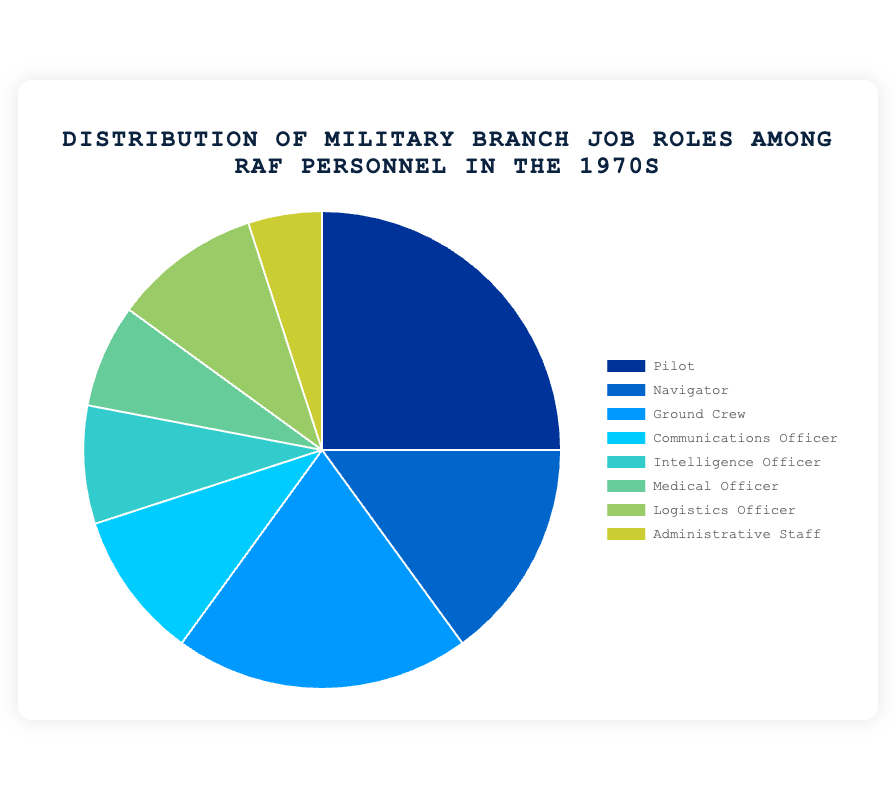What's the largest job role among RAF personnel? The largest job role can be identified by finding the segment with the largest percentage. In the figure, the "Pilot" segment has the highest percentage at 25%.
Answer: Pilot Which job roles have the same percentage? To identify job roles with the same percentage, examine the data for identical values. "Communications Officer" and "Logistics Officer" both have 10%.
Answer: Communications Officer and Logistics Officer What is the percentage difference between Pilots and Navigators? The percentage difference can be calculated by subtracting the percentage of Navigators from Pilots. This is 25% - 15% = 10%.
Answer: 10% How does the size of the Ground Crew segment compare to the Administrative Staff segment? By inspecting the percentages, Ground Crew is 20% and Administrative Staff is 5%. Ground Crew has a larger segment.
Answer: Ground Crew is larger What percentage of personnel are neither Pilots nor Ground Crew? First, sum the percentages of Pilots and Ground Crew: 25% + 20% = 45%. Subtract this sum from 100% to find the remaining percentage: 100% - 45% = 55%.
Answer: 55% Which job role segment is the smallest? The smallest segment is identified by the smallest percentage. "Administrative Staff" has the smallest percentage at 5%.
Answer: Administrative Staff How do Intelligence Officers compare to Medical Officers in terms of percentage? By comparing their percentages, Intelligence Officers have 8% while Medical Officers have 7%. Intelligence Officers have a slightly larger percentage.
Answer: Intelligence Officers What is the combined percentage of Navigators, Communications Officers, and Intelligence Officers? Sum the percentages of the three job roles: 15% (Navigators) + 10% (Communications Officers) + 8% (Intelligence Officers) = 33%.
Answer: 33% Visualize the colors for Pilots and Logistics Officers. What are the colors associated with these job roles? Pilots have a dark blue color, and Logistics Officers have a greenish-yellow color in the pie chart.
Answer: Pilots: dark blue, Logistics Officers: greenish-yellow What is the percentage of roles that deal directly with flights (Pilots and Navigators) versus those that do not? Sum the percentages of Pilots and Navigators: 25% + 15% = 40%. Subtract this from 100% to get non-flight roles: 100% - 40% = 60%.
Answer: 40% flight roles, 60% non-flight roles 